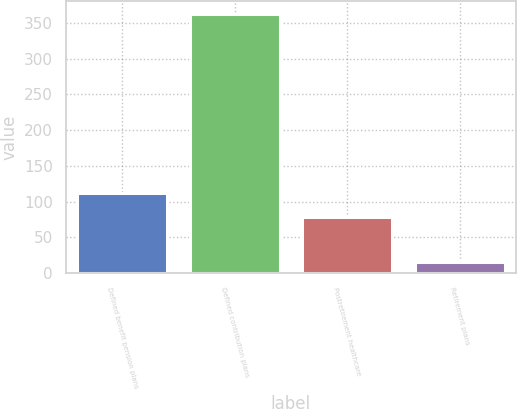Convert chart to OTSL. <chart><loc_0><loc_0><loc_500><loc_500><bar_chart><fcel>Defined benefit pension plans<fcel>Defined contribution plans<fcel>Postretirement healthcare<fcel>Retirement plans<nl><fcel>112.8<fcel>363<fcel>78<fcel>15<nl></chart> 